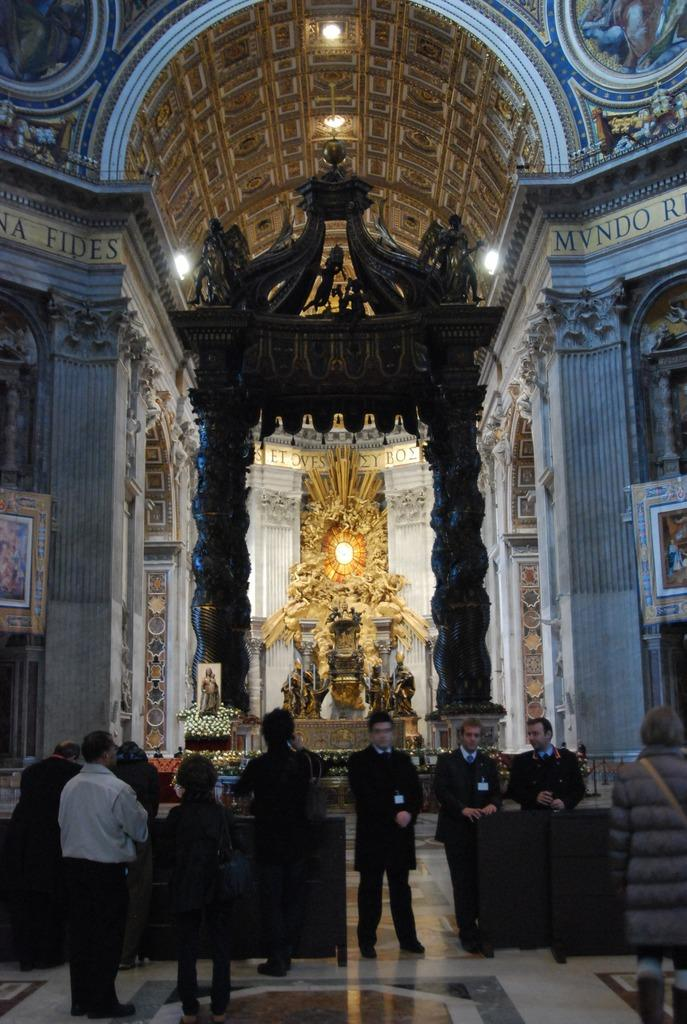What type of location is depicted in the image? The image is an inside view of a church. What can be seen on the floor of the church? There are persons standing on the floor. What architectural features are present in the image? There are frames and pillars in the image. What decorative elements can be seen in the image? There are flowers and lights in the image. Can you see a stick being used by any of the persons in the image? There is no stick visible in the image. What type of thumb is being displayed by the persons in the image? There is no thumb visible in the image, as it is not possible to see the persons' hands or fingers. 